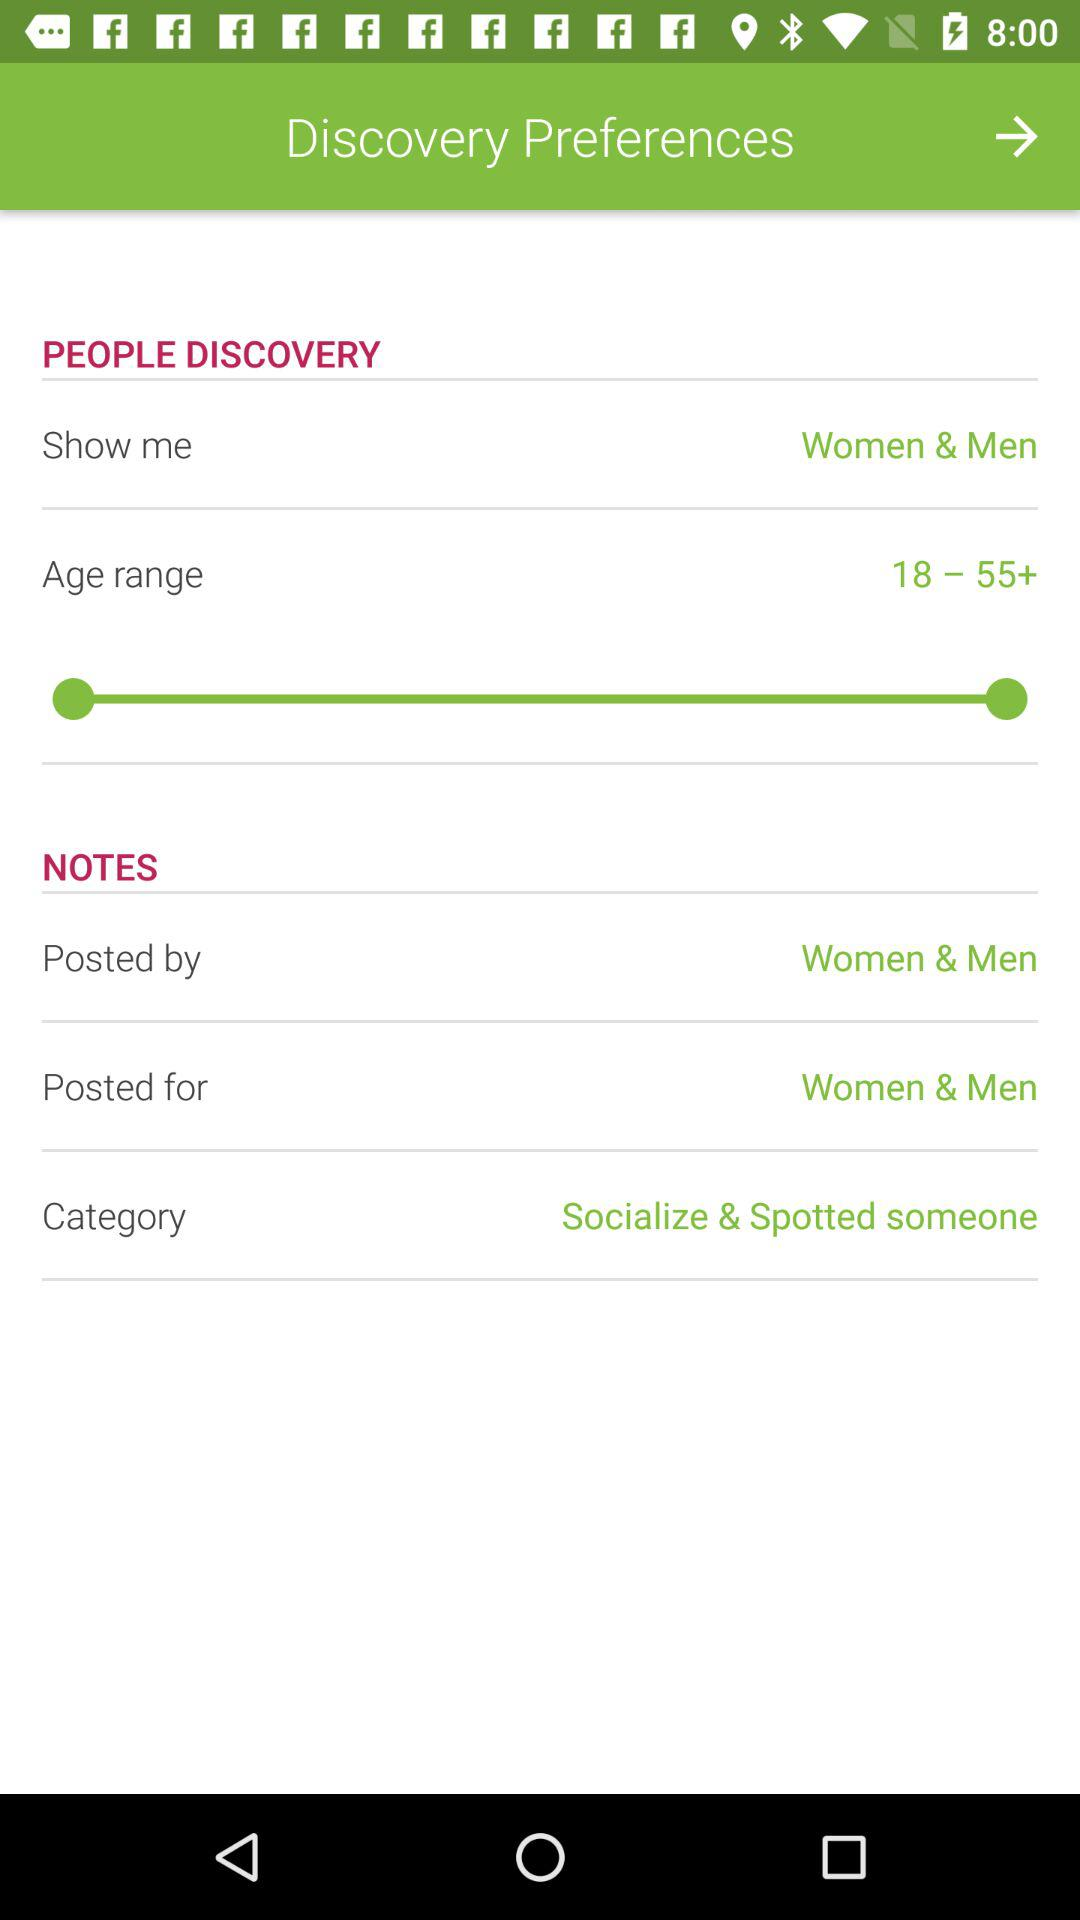For whom is it posted? It is posted for women and men. 